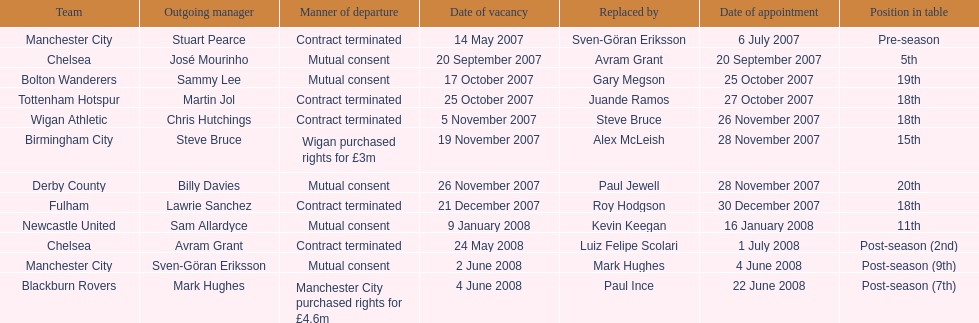What was the only team to place 5th called? Chelsea. Could you parse the entire table? {'header': ['Team', 'Outgoing manager', 'Manner of departure', 'Date of vacancy', 'Replaced by', 'Date of appointment', 'Position in table'], 'rows': [['Manchester City', 'Stuart Pearce', 'Contract terminated', '14 May 2007', 'Sven-Göran Eriksson', '6 July 2007', 'Pre-season'], ['Chelsea', 'José Mourinho', 'Mutual consent', '20 September 2007', 'Avram Grant', '20 September 2007', '5th'], ['Bolton Wanderers', 'Sammy Lee', 'Mutual consent', '17 October 2007', 'Gary Megson', '25 October 2007', '19th'], ['Tottenham Hotspur', 'Martin Jol', 'Contract terminated', '25 October 2007', 'Juande Ramos', '27 October 2007', '18th'], ['Wigan Athletic', 'Chris Hutchings', 'Contract terminated', '5 November 2007', 'Steve Bruce', '26 November 2007', '18th'], ['Birmingham City', 'Steve Bruce', 'Wigan purchased rights for £3m', '19 November 2007', 'Alex McLeish', '28 November 2007', '15th'], ['Derby County', 'Billy Davies', 'Mutual consent', '26 November 2007', 'Paul Jewell', '28 November 2007', '20th'], ['Fulham', 'Lawrie Sanchez', 'Contract terminated', '21 December 2007', 'Roy Hodgson', '30 December 2007', '18th'], ['Newcastle United', 'Sam Allardyce', 'Mutual consent', '9 January 2008', 'Kevin Keegan', '16 January 2008', '11th'], ['Chelsea', 'Avram Grant', 'Contract terminated', '24 May 2008', 'Luiz Felipe Scolari', '1 July 2008', 'Post-season (2nd)'], ['Manchester City', 'Sven-Göran Eriksson', 'Mutual consent', '2 June 2008', 'Mark Hughes', '4 June 2008', 'Post-season (9th)'], ['Blackburn Rovers', 'Mark Hughes', 'Manchester City purchased rights for £4.6m', '4 June 2008', 'Paul Ince', '22 June 2008', 'Post-season (7th)']]} 